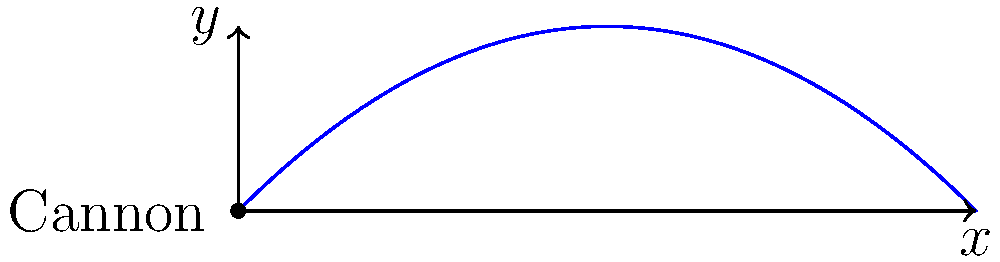During your investigation of a 17th-century battle, you discover records of a cannon used in the siege. According to eyewitness accounts, the cannonball was launched at an angle of 45° to the horizontal with an initial velocity of 50 m/s. Assuming no air resistance, what was the maximum height reached by the cannonball? (Use g = 9.8 m/s²) To find the maximum height of the projectile, we can follow these steps:

1) The trajectory of a projectile launched at an angle forms a parabola. The maximum height occurs at the vertex of this parabola.

2) We are given:
   - Initial velocity, $v_0 = 50$ m/s
   - Launch angle, $\theta = 45°$ (which is $\frac{\pi}{4}$ radians)
   - Acceleration due to gravity, $g = 9.8$ m/s²

3) The vertical component of the initial velocity is:
   $v_{0y} = v_0 \sin(\theta) = 50 \sin(45°) = 50 \cdot \frac{\sqrt{2}}{2} \approx 35.36$ m/s

4) The time to reach the maximum height is when the vertical velocity becomes zero:
   $t_{max} = \frac{v_{0y}}{g} = \frac{35.36}{9.8} \approx 3.61$ s

5) The maximum height can be calculated using the equation:
   $h_{max} = v_{0y}t_{max} - \frac{1}{2}gt_{max}^2$

6) Substituting the values:
   $h_{max} = (35.36)(3.61) - \frac{1}{2}(9.8)(3.61)^2$
   $h_{max} = 127.65 - 63.82 = 63.83$ m

Therefore, the maximum height reached by the cannonball is approximately 63.83 meters.
Answer: 63.83 meters 